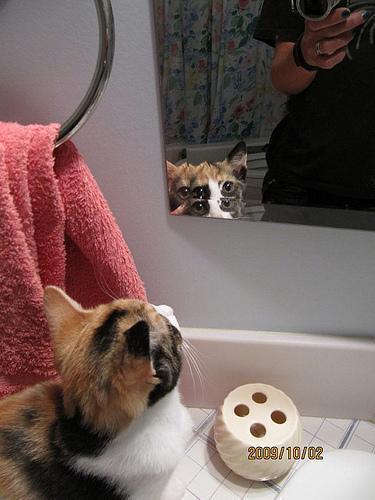How many clocks on the building?
Give a very brief answer. 0. 